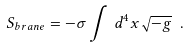<formula> <loc_0><loc_0><loc_500><loc_500>S _ { b r a n e } = - \sigma \int \, d ^ { 4 } x \sqrt { - g } \ .</formula> 